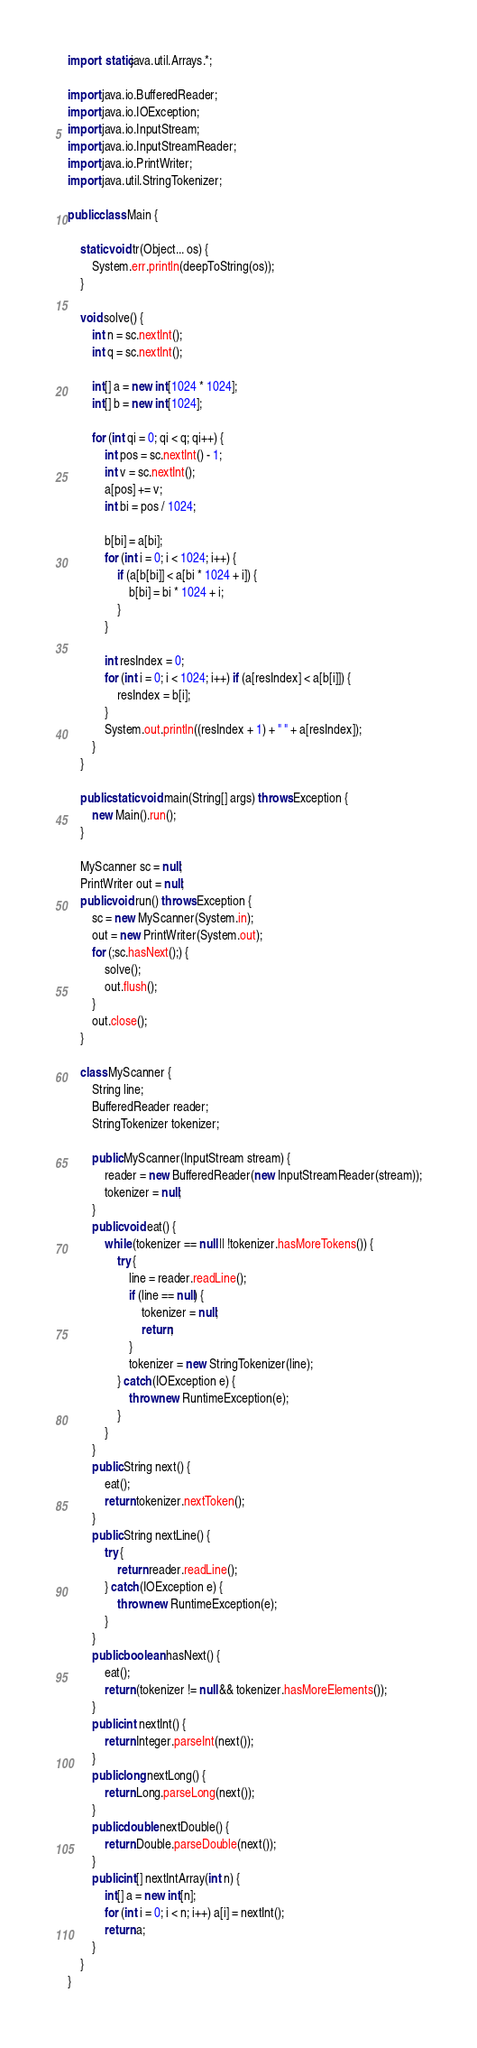Convert code to text. <code><loc_0><loc_0><loc_500><loc_500><_Java_>import static java.util.Arrays.*;

import java.io.BufferedReader;
import java.io.IOException;
import java.io.InputStream;
import java.io.InputStreamReader;
import java.io.PrintWriter;
import java.util.StringTokenizer;

public class Main {

	static void tr(Object... os) {
		System.err.println(deepToString(os));
	}

	void solve() {
		int n = sc.nextInt();
		int q = sc.nextInt();

		int[] a = new int[1024 * 1024];
		int[] b = new int[1024];

		for (int qi = 0; qi < q; qi++) {
			int pos = sc.nextInt() - 1;
			int v = sc.nextInt();
			a[pos] += v;
			int bi = pos / 1024;

			b[bi] = a[bi];
			for (int i = 0; i < 1024; i++) {
				if (a[b[bi]] < a[bi * 1024 + i]) {
					b[bi] = bi * 1024 + i;
				}
			}

			int resIndex = 0;
			for (int i = 0; i < 1024; i++) if (a[resIndex] < a[b[i]]) {
				resIndex = b[i];
			}
			System.out.println((resIndex + 1) + " " + a[resIndex]);
		}
	}

	public static void main(String[] args) throws Exception {
		new Main().run();
	}

	MyScanner sc = null;
	PrintWriter out = null;
	public void run() throws Exception {
		sc = new MyScanner(System.in);
		out = new PrintWriter(System.out);
		for (;sc.hasNext();) {
			solve();
			out.flush();
		}
		out.close();
	}

	class MyScanner {
		String line;
		BufferedReader reader;
		StringTokenizer tokenizer;

		public MyScanner(InputStream stream) {
			reader = new BufferedReader(new InputStreamReader(stream));
			tokenizer = null;
		}
		public void eat() {
			while (tokenizer == null || !tokenizer.hasMoreTokens()) {
				try {
					line = reader.readLine();
					if (line == null) {
						tokenizer = null;
						return;
					}
					tokenizer = new StringTokenizer(line);
				} catch (IOException e) {
					throw new RuntimeException(e);
				}
			}
		}
		public String next() {
			eat();
			return tokenizer.nextToken();
		}
		public String nextLine() {
			try {
				return reader.readLine();
			} catch (IOException e) {
				throw new RuntimeException(e);
			}
		}
		public boolean hasNext() {
			eat();
			return (tokenizer != null && tokenizer.hasMoreElements());
		}
		public int nextInt() {
			return Integer.parseInt(next());
		}
		public long nextLong() {
			return Long.parseLong(next());
		}
		public double nextDouble() {
			return Double.parseDouble(next());
		}
		public int[] nextIntArray(int n) {
			int[] a = new int[n];
			for (int i = 0; i < n; i++) a[i] = nextInt();
			return a;
		}
	}
}</code> 